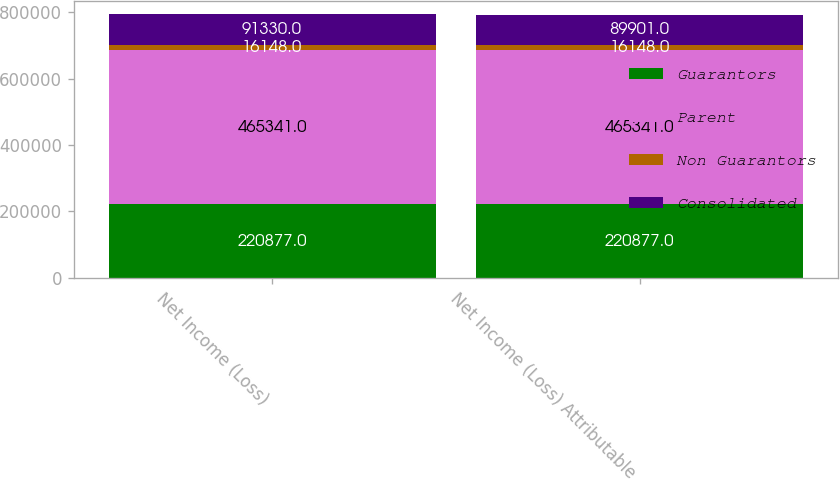Convert chart. <chart><loc_0><loc_0><loc_500><loc_500><stacked_bar_chart><ecel><fcel>Net Income (Loss)<fcel>Net Income (Loss) Attributable<nl><fcel>Guarantors<fcel>220877<fcel>220877<nl><fcel>Parent<fcel>465341<fcel>465341<nl><fcel>Non Guarantors<fcel>16148<fcel>16148<nl><fcel>Consolidated<fcel>91330<fcel>89901<nl></chart> 